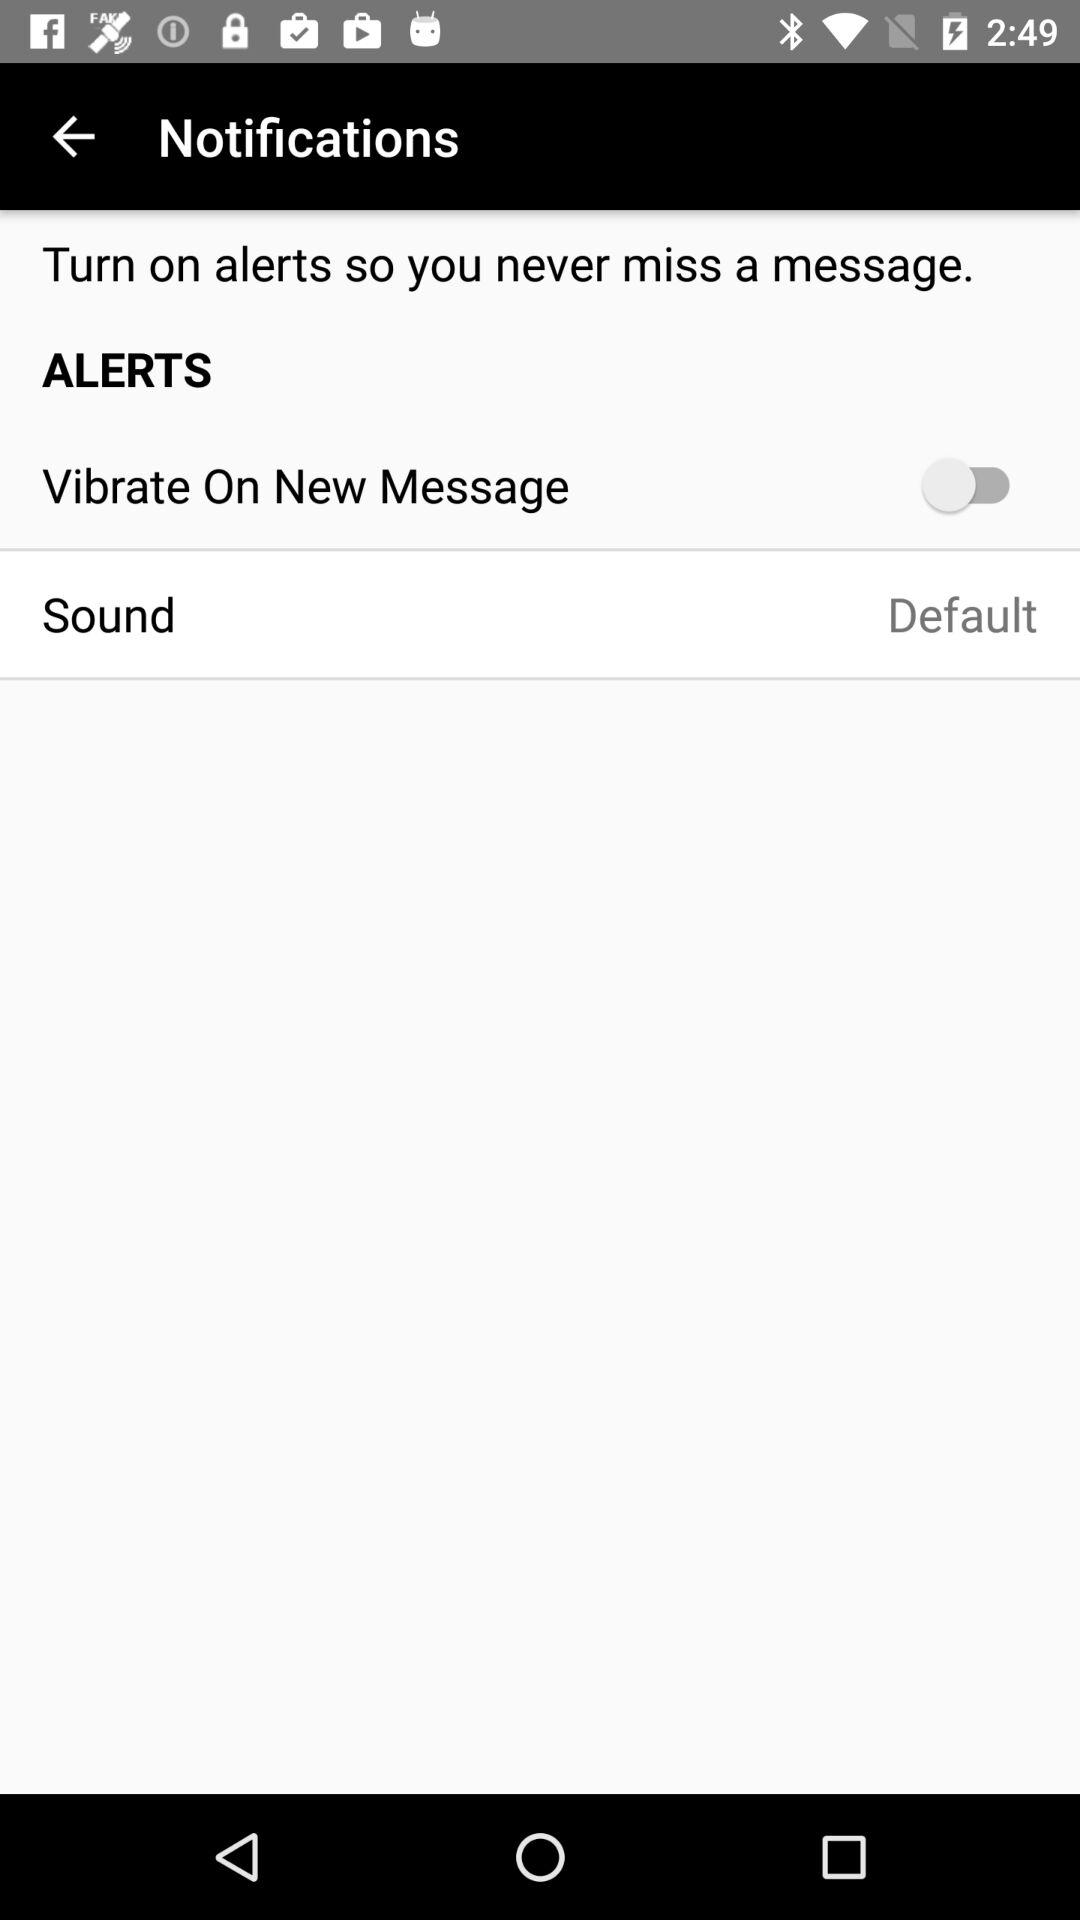What is the status of "Vibrate On New Message"? The status is "off". 